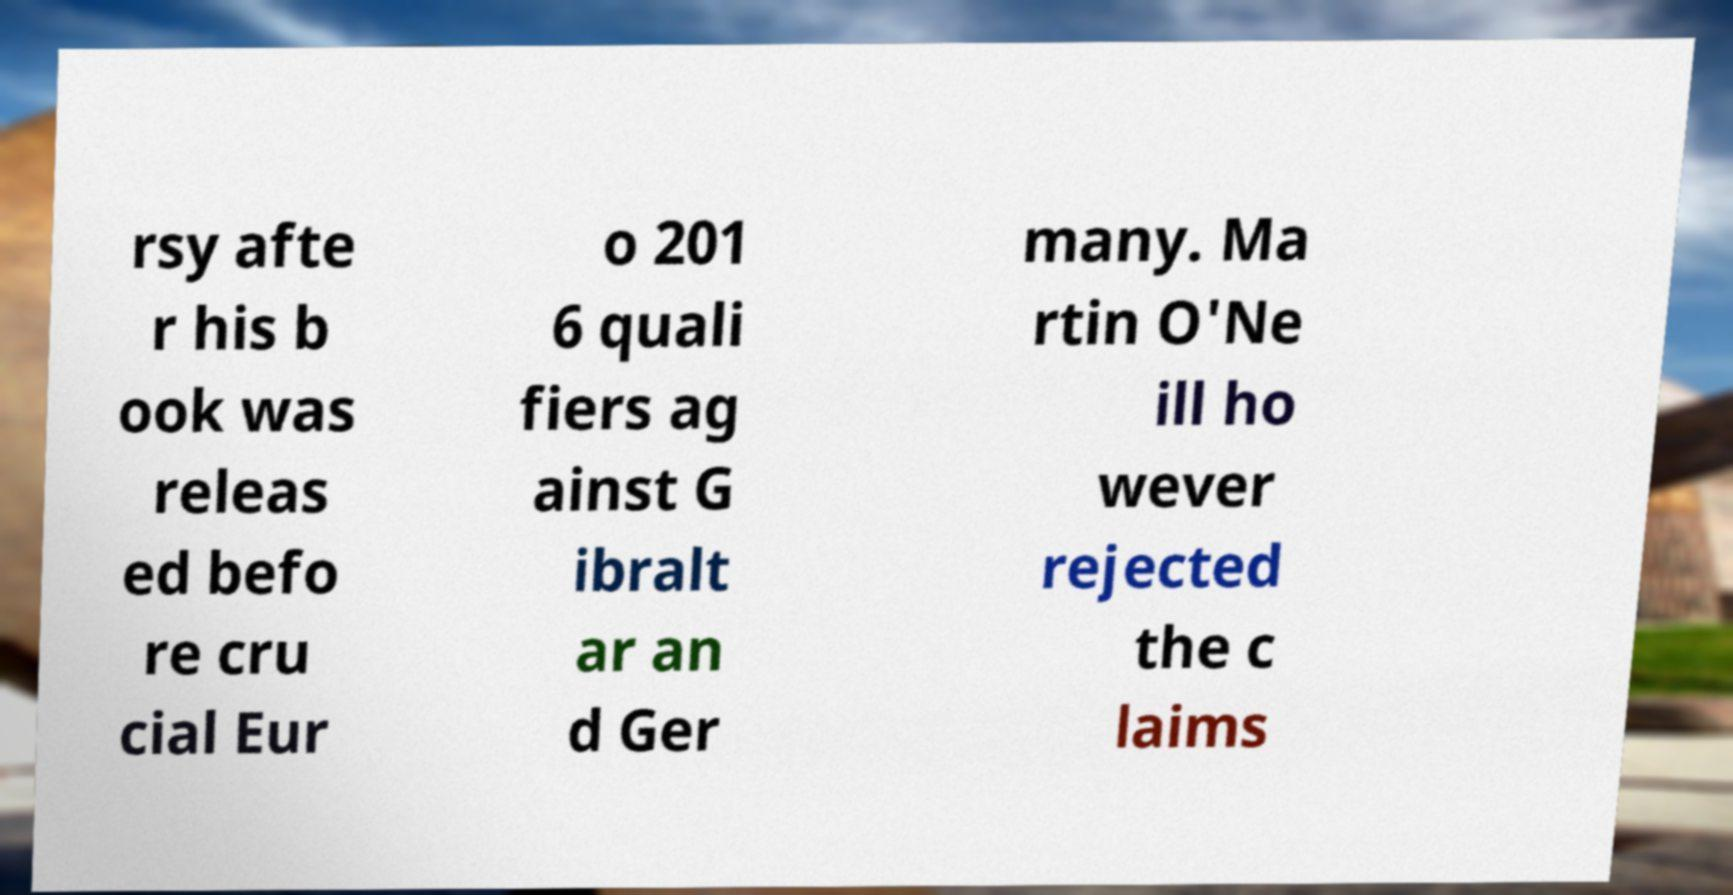I need the written content from this picture converted into text. Can you do that? rsy afte r his b ook was releas ed befo re cru cial Eur o 201 6 quali fiers ag ainst G ibralt ar an d Ger many. Ma rtin O'Ne ill ho wever rejected the c laims 